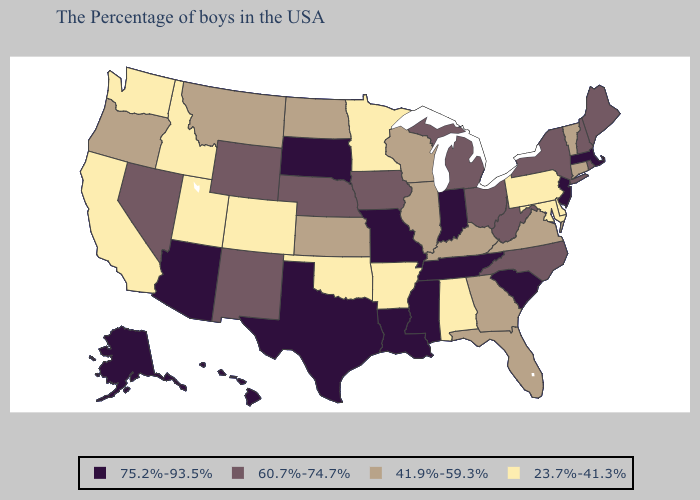Name the states that have a value in the range 60.7%-74.7%?
Concise answer only. Maine, Rhode Island, New Hampshire, New York, North Carolina, West Virginia, Ohio, Michigan, Iowa, Nebraska, Wyoming, New Mexico, Nevada. Does Alaska have the same value as New Mexico?
Be succinct. No. Among the states that border Wyoming , does South Dakota have the highest value?
Be succinct. Yes. Among the states that border Minnesota , does Iowa have the lowest value?
Keep it brief. No. Does Louisiana have the lowest value in the South?
Give a very brief answer. No. Does the map have missing data?
Write a very short answer. No. Is the legend a continuous bar?
Write a very short answer. No. Does the map have missing data?
Answer briefly. No. Name the states that have a value in the range 75.2%-93.5%?
Answer briefly. Massachusetts, New Jersey, South Carolina, Indiana, Tennessee, Mississippi, Louisiana, Missouri, Texas, South Dakota, Arizona, Alaska, Hawaii. What is the value of Indiana?
Be succinct. 75.2%-93.5%. Name the states that have a value in the range 23.7%-41.3%?
Answer briefly. Delaware, Maryland, Pennsylvania, Alabama, Arkansas, Minnesota, Oklahoma, Colorado, Utah, Idaho, California, Washington. Does Connecticut have the same value as Oklahoma?
Quick response, please. No. Does the map have missing data?
Quick response, please. No. Among the states that border Connecticut , does New York have the highest value?
Answer briefly. No. What is the lowest value in the USA?
Give a very brief answer. 23.7%-41.3%. 